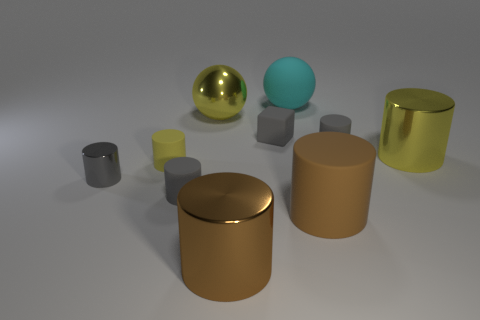Subtract all gray cubes. How many gray cylinders are left? 3 Subtract all yellow cylinders. How many cylinders are left? 5 Subtract all brown cylinders. How many cylinders are left? 5 Subtract 3 cylinders. How many cylinders are left? 4 Subtract all blue cylinders. Subtract all green cubes. How many cylinders are left? 7 Subtract all spheres. How many objects are left? 8 Add 2 large yellow spheres. How many large yellow spheres are left? 3 Add 3 large metallic balls. How many large metallic balls exist? 4 Subtract 1 yellow balls. How many objects are left? 9 Subtract all gray rubber blocks. Subtract all large blue objects. How many objects are left? 9 